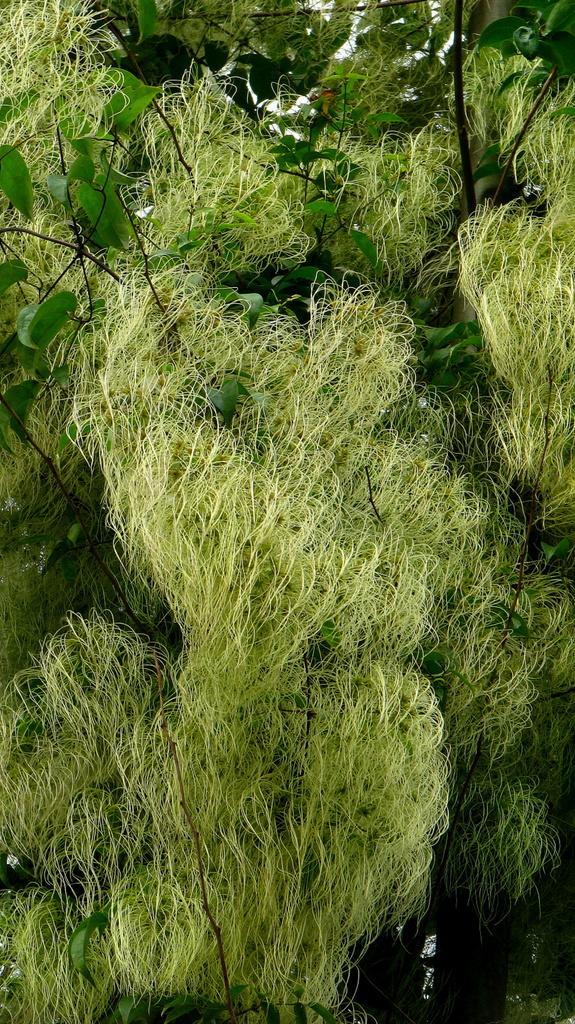Describe this image in one or two sentences. This image consists of trees. It has leaves. It is in green color. 